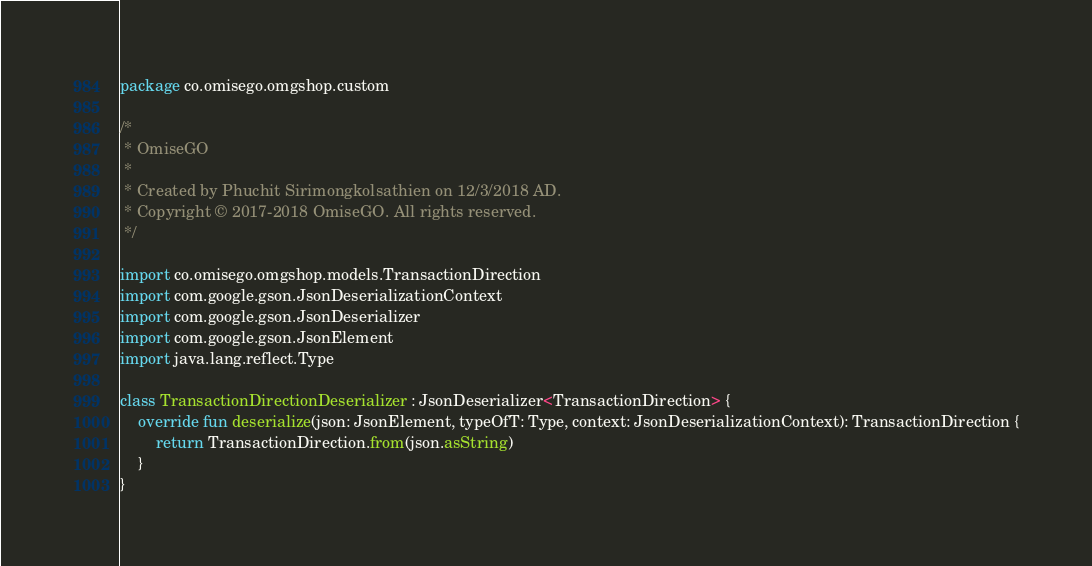<code> <loc_0><loc_0><loc_500><loc_500><_Kotlin_>package co.omisego.omgshop.custom

/*
 * OmiseGO
 *
 * Created by Phuchit Sirimongkolsathien on 12/3/2018 AD.
 * Copyright © 2017-2018 OmiseGO. All rights reserved.
 */

import co.omisego.omgshop.models.TransactionDirection
import com.google.gson.JsonDeserializationContext
import com.google.gson.JsonDeserializer
import com.google.gson.JsonElement
import java.lang.reflect.Type

class TransactionDirectionDeserializer : JsonDeserializer<TransactionDirection> {
    override fun deserialize(json: JsonElement, typeOfT: Type, context: JsonDeserializationContext): TransactionDirection {
        return TransactionDirection.from(json.asString)
    }
}
</code> 